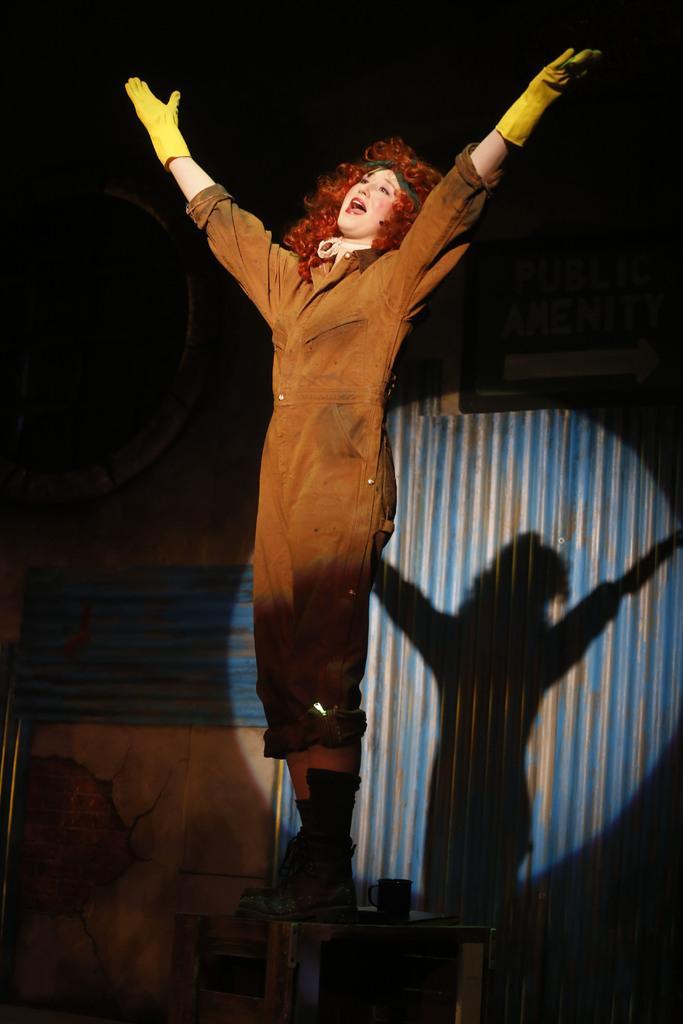How would you summarize this image in a sentence or two? In the center of the image we can see a person standing on the table. She is wearing a costume. In the background there is a wall and we can see a shadow on the wall. 